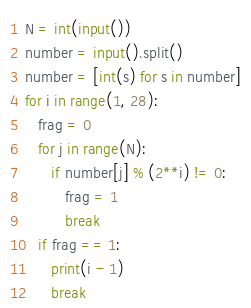Convert code to text. <code><loc_0><loc_0><loc_500><loc_500><_Python_>N = int(input())
number = input().split()
number = [int(s) for s in number]
for i in range(1, 28):
   frag = 0
   for j in range(N):
      if number[j] % (2**i) != 0:
         frag = 1
         break
   if frag == 1:
      print(i - 1)
      break</code> 